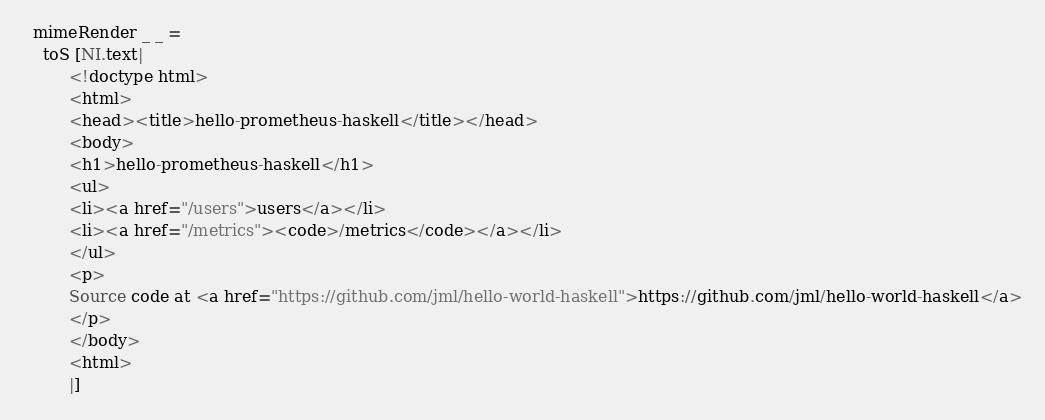<code> <loc_0><loc_0><loc_500><loc_500><_Haskell_>  mimeRender _ _ =
    toS [NI.text|
         <!doctype html>
         <html>
         <head><title>hello-prometheus-haskell</title></head>
         <body>
         <h1>hello-prometheus-haskell</h1>
         <ul>
         <li><a href="/users">users</a></li>
         <li><a href="/metrics"><code>/metrics</code></a></li>
         </ul>
         <p>
         Source code at <a href="https://github.com/jml/hello-world-haskell">https://github.com/jml/hello-world-haskell</a>
         </p>
         </body>
         <html>
         |]
</code> 